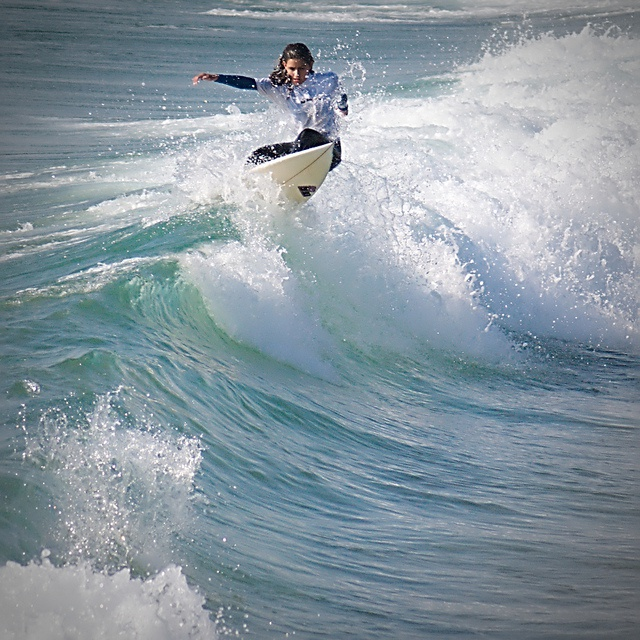Describe the objects in this image and their specific colors. I can see people in gray, darkgray, lightgray, and black tones and surfboard in gray, darkgray, lightgray, and tan tones in this image. 